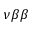Convert formula to latex. <formula><loc_0><loc_0><loc_500><loc_500>\nu \beta \beta</formula> 